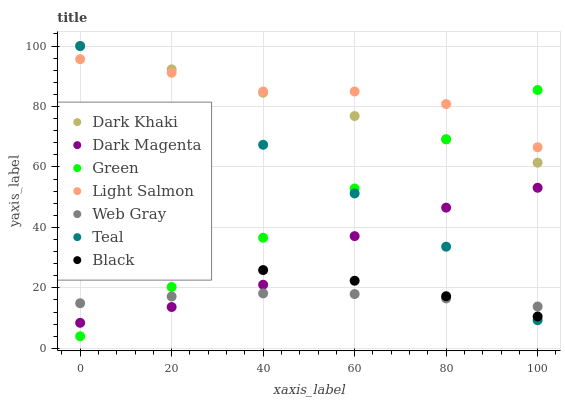Does Web Gray have the minimum area under the curve?
Answer yes or no. Yes. Does Light Salmon have the maximum area under the curve?
Answer yes or no. Yes. Does Dark Magenta have the minimum area under the curve?
Answer yes or no. No. Does Dark Magenta have the maximum area under the curve?
Answer yes or no. No. Is Green the smoothest?
Answer yes or no. Yes. Is Teal the roughest?
Answer yes or no. Yes. Is Web Gray the smoothest?
Answer yes or no. No. Is Web Gray the roughest?
Answer yes or no. No. Does Green have the lowest value?
Answer yes or no. Yes. Does Web Gray have the lowest value?
Answer yes or no. No. Does Teal have the highest value?
Answer yes or no. Yes. Does Dark Magenta have the highest value?
Answer yes or no. No. Is Black less than Light Salmon?
Answer yes or no. Yes. Is Dark Khaki greater than Web Gray?
Answer yes or no. Yes. Does Teal intersect Web Gray?
Answer yes or no. Yes. Is Teal less than Web Gray?
Answer yes or no. No. Is Teal greater than Web Gray?
Answer yes or no. No. Does Black intersect Light Salmon?
Answer yes or no. No. 